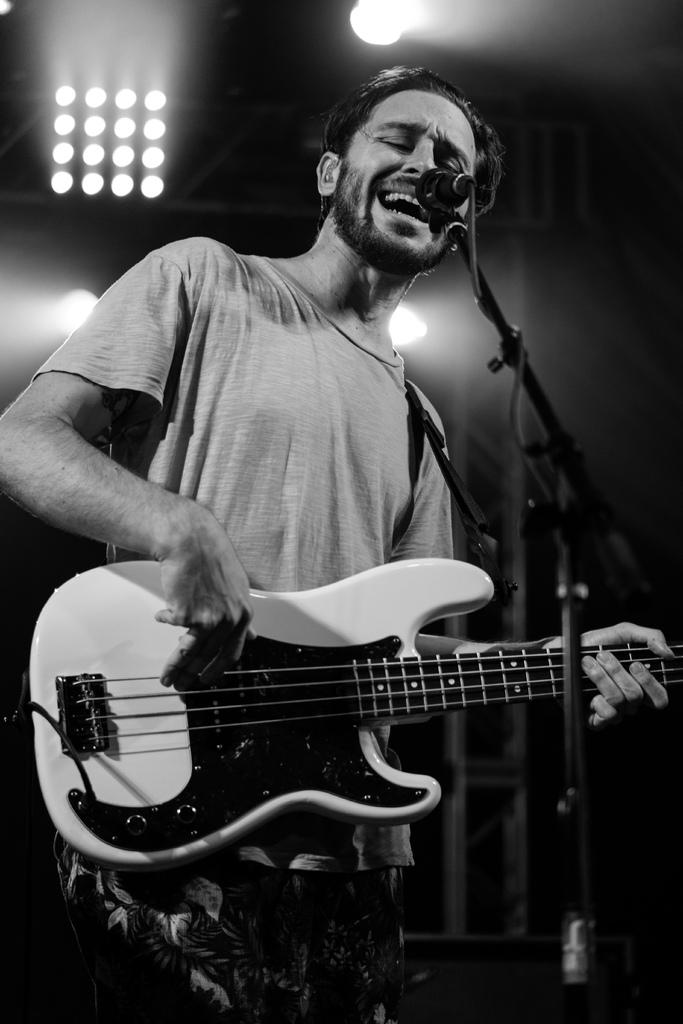What is the main subject of the image? There is a person in the image. Where is the person located in the image? The person is standing at the left side of the image. What is the person holding in his hands? The person is holding a guitar in his hands. What object is in front of the person? There is a microphone in front of the person. What type of wrench is the person using to tune the guitar in the image? There is no wrench present in the image, and the person is not tuning the guitar. Can you see any sea creatures in the image? There are no sea creatures visible in the image; it features a person holding a guitar and standing near a microphone. 